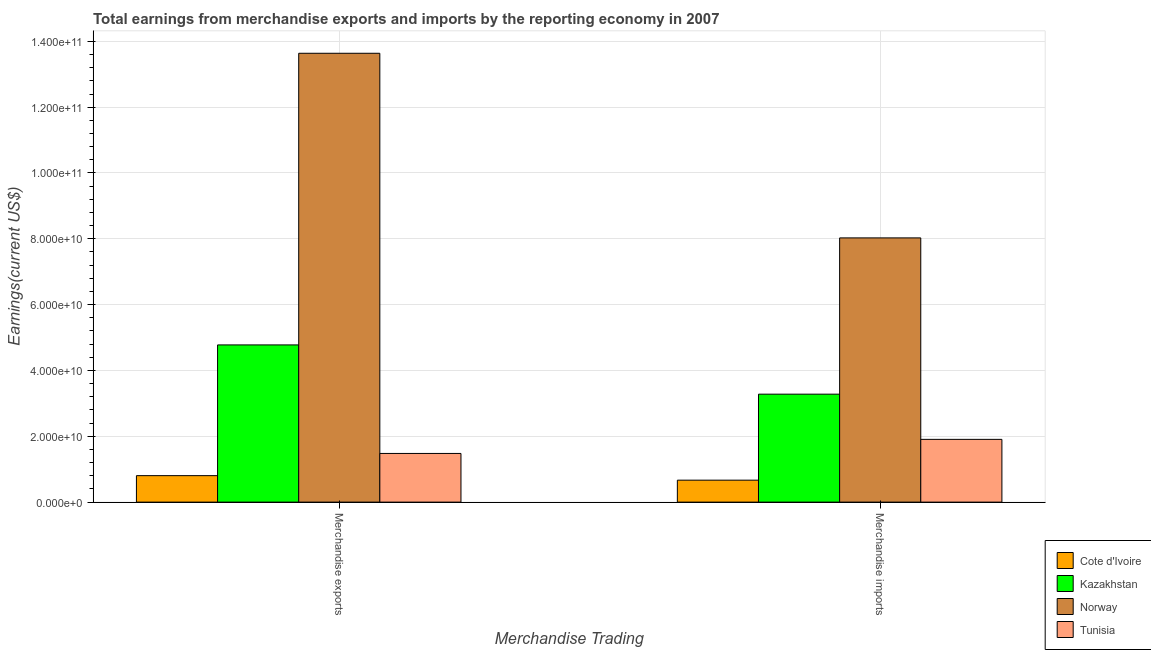How many bars are there on the 1st tick from the left?
Your answer should be very brief. 4. How many bars are there on the 1st tick from the right?
Offer a very short reply. 4. What is the label of the 2nd group of bars from the left?
Provide a succinct answer. Merchandise imports. What is the earnings from merchandise exports in Norway?
Give a very brief answer. 1.36e+11. Across all countries, what is the maximum earnings from merchandise exports?
Make the answer very short. 1.36e+11. Across all countries, what is the minimum earnings from merchandise exports?
Ensure brevity in your answer.  8.05e+09. In which country was the earnings from merchandise imports maximum?
Provide a short and direct response. Norway. In which country was the earnings from merchandise exports minimum?
Your response must be concise. Cote d'Ivoire. What is the total earnings from merchandise imports in the graph?
Provide a succinct answer. 1.39e+11. What is the difference between the earnings from merchandise exports in Kazakhstan and that in Norway?
Keep it short and to the point. -8.86e+1. What is the difference between the earnings from merchandise exports in Tunisia and the earnings from merchandise imports in Norway?
Make the answer very short. -6.55e+1. What is the average earnings from merchandise imports per country?
Make the answer very short. 3.47e+1. What is the difference between the earnings from merchandise imports and earnings from merchandise exports in Norway?
Give a very brief answer. -5.61e+1. In how many countries, is the earnings from merchandise exports greater than 72000000000 US$?
Your answer should be very brief. 1. What is the ratio of the earnings from merchandise exports in Kazakhstan to that in Tunisia?
Provide a succinct answer. 3.23. In how many countries, is the earnings from merchandise imports greater than the average earnings from merchandise imports taken over all countries?
Ensure brevity in your answer.  1. What does the 4th bar from the left in Merchandise exports represents?
Provide a short and direct response. Tunisia. What does the 1st bar from the right in Merchandise imports represents?
Give a very brief answer. Tunisia. Are all the bars in the graph horizontal?
Your answer should be very brief. No. What is the difference between two consecutive major ticks on the Y-axis?
Offer a terse response. 2.00e+1. Where does the legend appear in the graph?
Provide a succinct answer. Bottom right. How many legend labels are there?
Provide a short and direct response. 4. What is the title of the graph?
Your response must be concise. Total earnings from merchandise exports and imports by the reporting economy in 2007. Does "Russian Federation" appear as one of the legend labels in the graph?
Make the answer very short. No. What is the label or title of the X-axis?
Provide a succinct answer. Merchandise Trading. What is the label or title of the Y-axis?
Your answer should be compact. Earnings(current US$). What is the Earnings(current US$) of Cote d'Ivoire in Merchandise exports?
Give a very brief answer. 8.05e+09. What is the Earnings(current US$) of Kazakhstan in Merchandise exports?
Your response must be concise. 4.78e+1. What is the Earnings(current US$) in Norway in Merchandise exports?
Offer a terse response. 1.36e+11. What is the Earnings(current US$) of Tunisia in Merchandise exports?
Offer a terse response. 1.48e+1. What is the Earnings(current US$) of Cote d'Ivoire in Merchandise imports?
Your response must be concise. 6.67e+09. What is the Earnings(current US$) of Kazakhstan in Merchandise imports?
Your answer should be very brief. 3.28e+1. What is the Earnings(current US$) of Norway in Merchandise imports?
Offer a very short reply. 8.03e+1. What is the Earnings(current US$) in Tunisia in Merchandise imports?
Provide a succinct answer. 1.91e+1. Across all Merchandise Trading, what is the maximum Earnings(current US$) of Cote d'Ivoire?
Your answer should be very brief. 8.05e+09. Across all Merchandise Trading, what is the maximum Earnings(current US$) in Kazakhstan?
Ensure brevity in your answer.  4.78e+1. Across all Merchandise Trading, what is the maximum Earnings(current US$) of Norway?
Your response must be concise. 1.36e+11. Across all Merchandise Trading, what is the maximum Earnings(current US$) in Tunisia?
Give a very brief answer. 1.91e+1. Across all Merchandise Trading, what is the minimum Earnings(current US$) in Cote d'Ivoire?
Offer a very short reply. 6.67e+09. Across all Merchandise Trading, what is the minimum Earnings(current US$) in Kazakhstan?
Offer a very short reply. 3.28e+1. Across all Merchandise Trading, what is the minimum Earnings(current US$) in Norway?
Provide a succinct answer. 8.03e+1. Across all Merchandise Trading, what is the minimum Earnings(current US$) in Tunisia?
Your answer should be compact. 1.48e+1. What is the total Earnings(current US$) in Cote d'Ivoire in the graph?
Ensure brevity in your answer.  1.47e+1. What is the total Earnings(current US$) in Kazakhstan in the graph?
Your answer should be compact. 8.06e+1. What is the total Earnings(current US$) in Norway in the graph?
Keep it short and to the point. 2.17e+11. What is the total Earnings(current US$) in Tunisia in the graph?
Provide a short and direct response. 3.39e+1. What is the difference between the Earnings(current US$) in Cote d'Ivoire in Merchandise exports and that in Merchandise imports?
Make the answer very short. 1.37e+09. What is the difference between the Earnings(current US$) in Kazakhstan in Merchandise exports and that in Merchandise imports?
Ensure brevity in your answer.  1.50e+1. What is the difference between the Earnings(current US$) of Norway in Merchandise exports and that in Merchandise imports?
Offer a terse response. 5.61e+1. What is the difference between the Earnings(current US$) of Tunisia in Merchandise exports and that in Merchandise imports?
Your answer should be compact. -4.28e+09. What is the difference between the Earnings(current US$) in Cote d'Ivoire in Merchandise exports and the Earnings(current US$) in Kazakhstan in Merchandise imports?
Your answer should be compact. -2.48e+1. What is the difference between the Earnings(current US$) of Cote d'Ivoire in Merchandise exports and the Earnings(current US$) of Norway in Merchandise imports?
Provide a succinct answer. -7.22e+1. What is the difference between the Earnings(current US$) in Cote d'Ivoire in Merchandise exports and the Earnings(current US$) in Tunisia in Merchandise imports?
Offer a terse response. -1.10e+1. What is the difference between the Earnings(current US$) in Kazakhstan in Merchandise exports and the Earnings(current US$) in Norway in Merchandise imports?
Keep it short and to the point. -3.25e+1. What is the difference between the Earnings(current US$) in Kazakhstan in Merchandise exports and the Earnings(current US$) in Tunisia in Merchandise imports?
Offer a very short reply. 2.87e+1. What is the difference between the Earnings(current US$) of Norway in Merchandise exports and the Earnings(current US$) of Tunisia in Merchandise imports?
Offer a very short reply. 1.17e+11. What is the average Earnings(current US$) in Cote d'Ivoire per Merchandise Trading?
Provide a succinct answer. 7.36e+09. What is the average Earnings(current US$) in Kazakhstan per Merchandise Trading?
Make the answer very short. 4.03e+1. What is the average Earnings(current US$) of Norway per Merchandise Trading?
Provide a short and direct response. 1.08e+11. What is the average Earnings(current US$) in Tunisia per Merchandise Trading?
Make the answer very short. 1.69e+1. What is the difference between the Earnings(current US$) in Cote d'Ivoire and Earnings(current US$) in Kazakhstan in Merchandise exports?
Your answer should be compact. -3.97e+1. What is the difference between the Earnings(current US$) of Cote d'Ivoire and Earnings(current US$) of Norway in Merchandise exports?
Offer a very short reply. -1.28e+11. What is the difference between the Earnings(current US$) of Cote d'Ivoire and Earnings(current US$) of Tunisia in Merchandise exports?
Make the answer very short. -6.75e+09. What is the difference between the Earnings(current US$) in Kazakhstan and Earnings(current US$) in Norway in Merchandise exports?
Ensure brevity in your answer.  -8.86e+1. What is the difference between the Earnings(current US$) in Kazakhstan and Earnings(current US$) in Tunisia in Merchandise exports?
Provide a succinct answer. 3.30e+1. What is the difference between the Earnings(current US$) of Norway and Earnings(current US$) of Tunisia in Merchandise exports?
Keep it short and to the point. 1.22e+11. What is the difference between the Earnings(current US$) in Cote d'Ivoire and Earnings(current US$) in Kazakhstan in Merchandise imports?
Make the answer very short. -2.61e+1. What is the difference between the Earnings(current US$) in Cote d'Ivoire and Earnings(current US$) in Norway in Merchandise imports?
Give a very brief answer. -7.36e+1. What is the difference between the Earnings(current US$) of Cote d'Ivoire and Earnings(current US$) of Tunisia in Merchandise imports?
Provide a succinct answer. -1.24e+1. What is the difference between the Earnings(current US$) in Kazakhstan and Earnings(current US$) in Norway in Merchandise imports?
Your answer should be very brief. -4.75e+1. What is the difference between the Earnings(current US$) in Kazakhstan and Earnings(current US$) in Tunisia in Merchandise imports?
Provide a short and direct response. 1.37e+1. What is the difference between the Earnings(current US$) of Norway and Earnings(current US$) of Tunisia in Merchandise imports?
Provide a succinct answer. 6.12e+1. What is the ratio of the Earnings(current US$) of Cote d'Ivoire in Merchandise exports to that in Merchandise imports?
Offer a terse response. 1.21. What is the ratio of the Earnings(current US$) of Kazakhstan in Merchandise exports to that in Merchandise imports?
Your answer should be compact. 1.46. What is the ratio of the Earnings(current US$) of Norway in Merchandise exports to that in Merchandise imports?
Your response must be concise. 1.7. What is the ratio of the Earnings(current US$) in Tunisia in Merchandise exports to that in Merchandise imports?
Your answer should be compact. 0.78. What is the difference between the highest and the second highest Earnings(current US$) of Cote d'Ivoire?
Make the answer very short. 1.37e+09. What is the difference between the highest and the second highest Earnings(current US$) of Kazakhstan?
Your answer should be very brief. 1.50e+1. What is the difference between the highest and the second highest Earnings(current US$) of Norway?
Provide a short and direct response. 5.61e+1. What is the difference between the highest and the second highest Earnings(current US$) of Tunisia?
Keep it short and to the point. 4.28e+09. What is the difference between the highest and the lowest Earnings(current US$) in Cote d'Ivoire?
Make the answer very short. 1.37e+09. What is the difference between the highest and the lowest Earnings(current US$) in Kazakhstan?
Your answer should be very brief. 1.50e+1. What is the difference between the highest and the lowest Earnings(current US$) of Norway?
Keep it short and to the point. 5.61e+1. What is the difference between the highest and the lowest Earnings(current US$) of Tunisia?
Provide a succinct answer. 4.28e+09. 